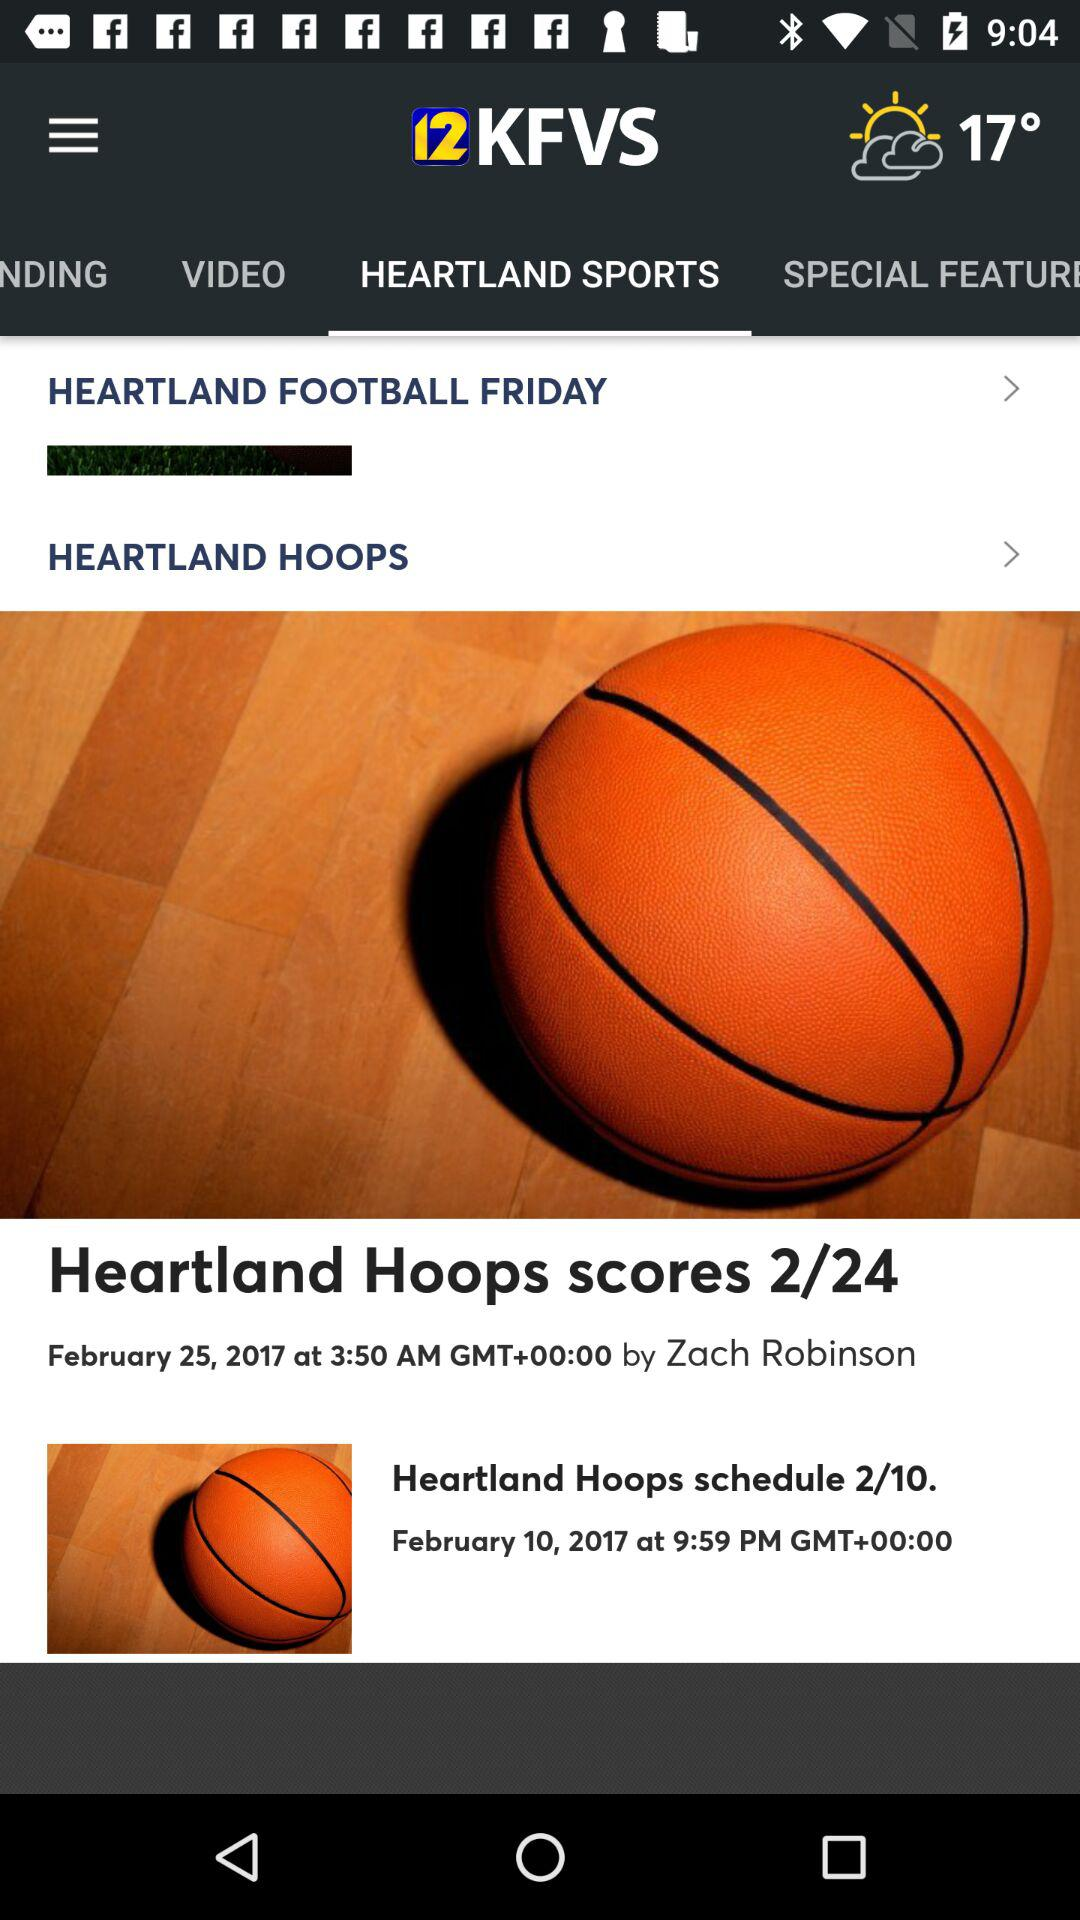What tab am I using? The tab you are using is "HEARTLAND SPORTS". 